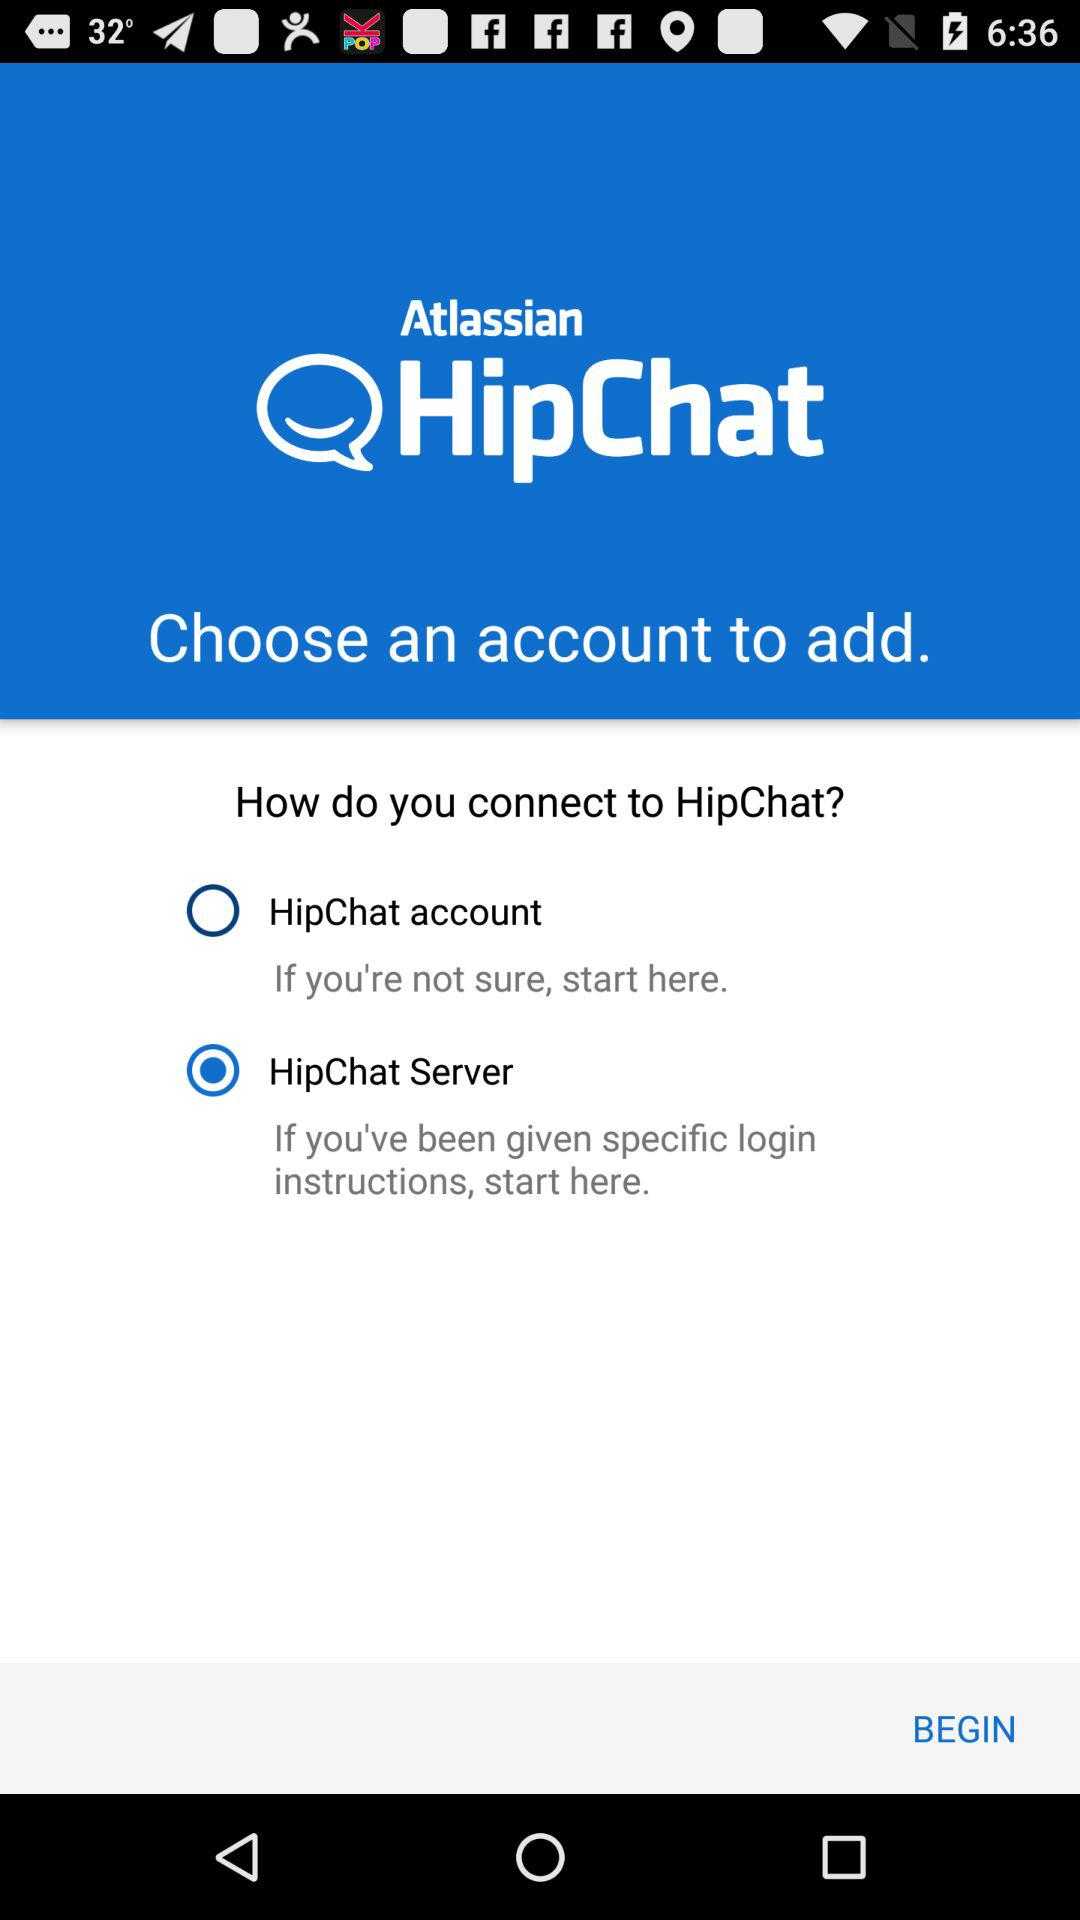Which version of the "HipChat" application is this?
When the provided information is insufficient, respond with <no answer>. <no answer> 